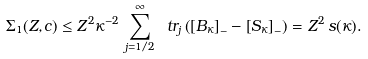Convert formula to latex. <formula><loc_0><loc_0><loc_500><loc_500>\Sigma _ { 1 } ( Z , c ) \leq Z ^ { 2 } \kappa ^ { - 2 } \, \sum _ { j = 1 / 2 } ^ { \infty } \ t r _ { j } \left ( \left [ B _ { \kappa } \right ] _ { - } - \left [ S _ { \kappa } \right ] _ { - } \right ) = Z ^ { 2 } \, s ( \kappa ) .</formula> 